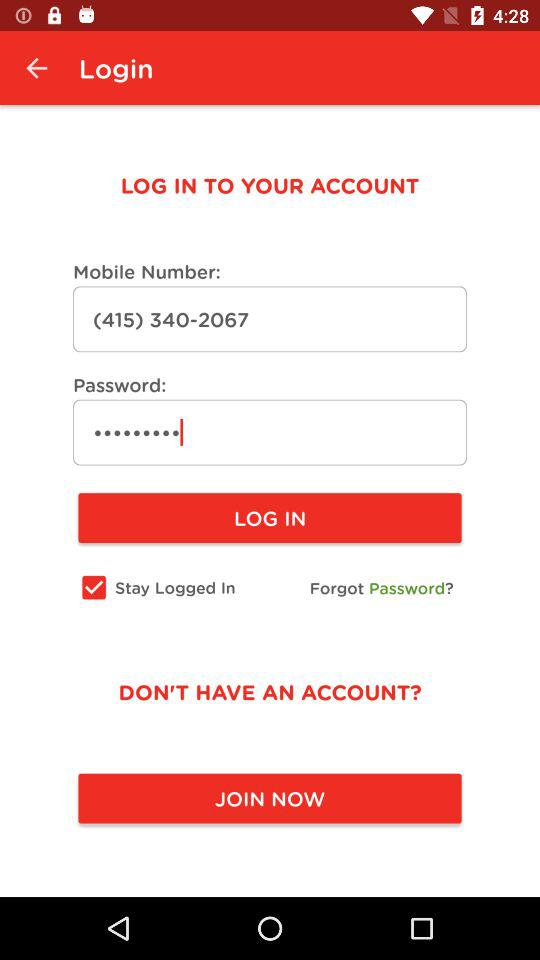What is the mobile number? The mobile number is (415) 340-2067. 